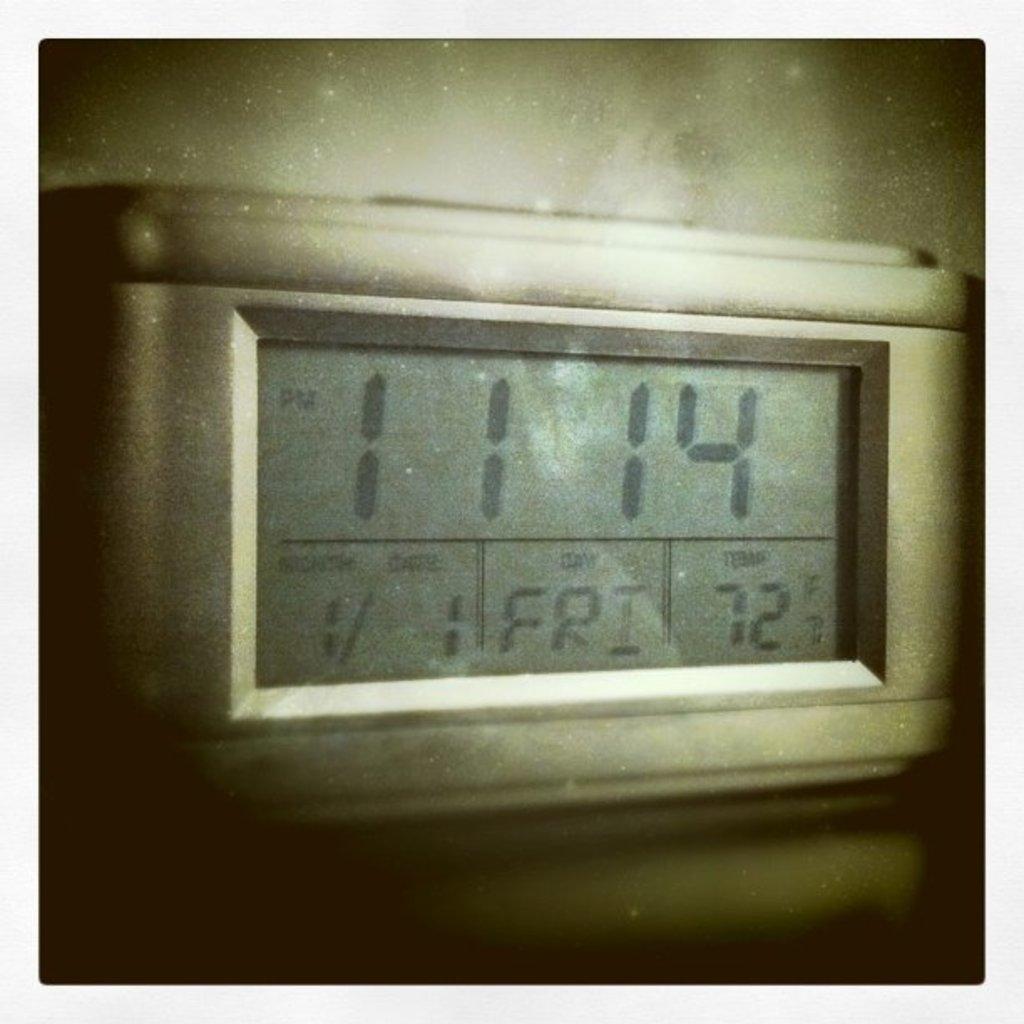What is the time shown?
Make the answer very short. 11:14. 